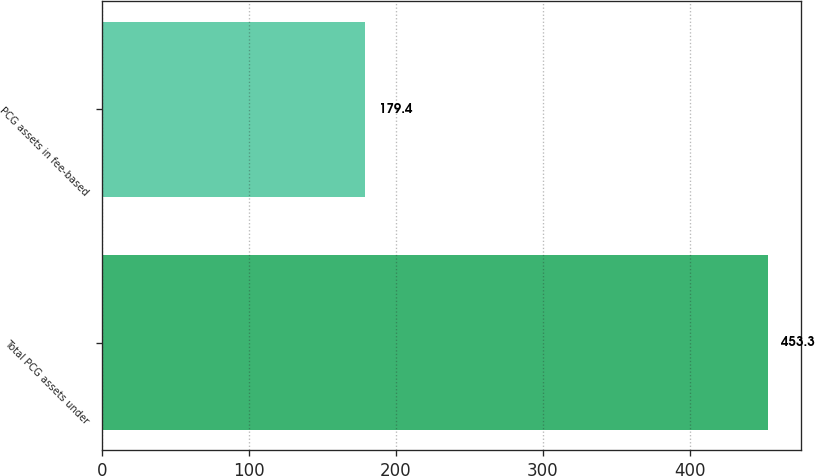Convert chart. <chart><loc_0><loc_0><loc_500><loc_500><bar_chart><fcel>Total PCG assets under<fcel>PCG assets in fee-based<nl><fcel>453.3<fcel>179.4<nl></chart> 